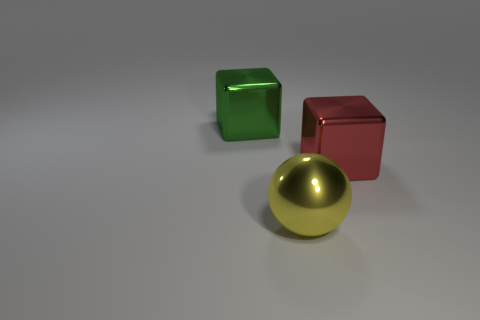How many other things are made of the same material as the large yellow thing?
Your response must be concise. 2. There is a yellow object; what number of big red objects are in front of it?
Your answer should be very brief. 0. The yellow metal thing is what size?
Offer a terse response. Large. There is a block that is the same size as the green thing; what color is it?
Offer a very short reply. Red. Is there a big cylinder of the same color as the ball?
Provide a short and direct response. No. What is the material of the big green object?
Offer a terse response. Metal. How many big yellow spheres are there?
Offer a very short reply. 1. There is a large shiny cube that is left of the yellow shiny object; is it the same color as the thing that is on the right side of the shiny sphere?
Give a very brief answer. No. There is a large metallic thing right of the big yellow shiny thing; what color is it?
Offer a very short reply. Red. Are the big object that is on the right side of the yellow ball and the green block made of the same material?
Give a very brief answer. Yes. 